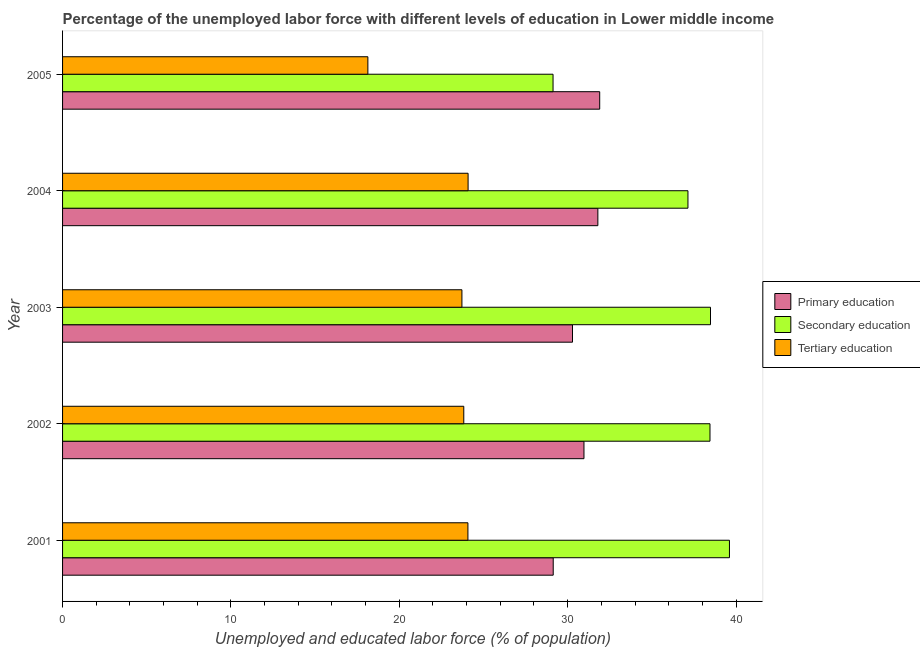How many different coloured bars are there?
Ensure brevity in your answer.  3. How many groups of bars are there?
Your answer should be compact. 5. Are the number of bars per tick equal to the number of legend labels?
Give a very brief answer. Yes. Are the number of bars on each tick of the Y-axis equal?
Offer a terse response. Yes. How many bars are there on the 1st tick from the top?
Provide a short and direct response. 3. How many bars are there on the 4th tick from the bottom?
Provide a short and direct response. 3. What is the label of the 1st group of bars from the top?
Offer a terse response. 2005. What is the percentage of labor force who received secondary education in 2004?
Provide a short and direct response. 37.14. Across all years, what is the maximum percentage of labor force who received secondary education?
Make the answer very short. 39.61. Across all years, what is the minimum percentage of labor force who received primary education?
Provide a succinct answer. 29.14. In which year was the percentage of labor force who received secondary education maximum?
Provide a short and direct response. 2001. In which year was the percentage of labor force who received secondary education minimum?
Your answer should be very brief. 2005. What is the total percentage of labor force who received tertiary education in the graph?
Your response must be concise. 113.84. What is the difference between the percentage of labor force who received primary education in 2001 and that in 2004?
Give a very brief answer. -2.65. What is the difference between the percentage of labor force who received primary education in 2004 and the percentage of labor force who received tertiary education in 2001?
Provide a succinct answer. 7.72. What is the average percentage of labor force who received secondary education per year?
Give a very brief answer. 36.56. In the year 2001, what is the difference between the percentage of labor force who received secondary education and percentage of labor force who received primary education?
Keep it short and to the point. 10.47. In how many years, is the percentage of labor force who received secondary education greater than 36 %?
Ensure brevity in your answer.  4. What is the ratio of the percentage of labor force who received primary education in 2001 to that in 2003?
Your response must be concise. 0.96. Is the percentage of labor force who received tertiary education in 2003 less than that in 2004?
Provide a succinct answer. Yes. Is the difference between the percentage of labor force who received primary education in 2003 and 2004 greater than the difference between the percentage of labor force who received secondary education in 2003 and 2004?
Keep it short and to the point. No. What is the difference between the highest and the second highest percentage of labor force who received secondary education?
Provide a short and direct response. 1.13. What is the difference between the highest and the lowest percentage of labor force who received primary education?
Keep it short and to the point. 2.76. What does the 3rd bar from the bottom in 2002 represents?
Offer a very short reply. Tertiary education. Is it the case that in every year, the sum of the percentage of labor force who received primary education and percentage of labor force who received secondary education is greater than the percentage of labor force who received tertiary education?
Your answer should be compact. Yes. How many years are there in the graph?
Provide a succinct answer. 5. Are the values on the major ticks of X-axis written in scientific E-notation?
Give a very brief answer. No. Does the graph contain any zero values?
Ensure brevity in your answer.  No. How many legend labels are there?
Offer a very short reply. 3. What is the title of the graph?
Keep it short and to the point. Percentage of the unemployed labor force with different levels of education in Lower middle income. Does "Oil" appear as one of the legend labels in the graph?
Ensure brevity in your answer.  No. What is the label or title of the X-axis?
Your answer should be very brief. Unemployed and educated labor force (% of population). What is the label or title of the Y-axis?
Offer a terse response. Year. What is the Unemployed and educated labor force (% of population) of Primary education in 2001?
Your answer should be compact. 29.14. What is the Unemployed and educated labor force (% of population) of Secondary education in 2001?
Provide a short and direct response. 39.61. What is the Unemployed and educated labor force (% of population) in Tertiary education in 2001?
Offer a terse response. 24.08. What is the Unemployed and educated labor force (% of population) of Primary education in 2002?
Provide a succinct answer. 30.97. What is the Unemployed and educated labor force (% of population) in Secondary education in 2002?
Provide a succinct answer. 38.45. What is the Unemployed and educated labor force (% of population) in Tertiary education in 2002?
Ensure brevity in your answer.  23.83. What is the Unemployed and educated labor force (% of population) of Primary education in 2003?
Your answer should be very brief. 30.29. What is the Unemployed and educated labor force (% of population) in Secondary education in 2003?
Provide a succinct answer. 38.48. What is the Unemployed and educated labor force (% of population) in Tertiary education in 2003?
Keep it short and to the point. 23.72. What is the Unemployed and educated labor force (% of population) in Primary education in 2004?
Your response must be concise. 31.79. What is the Unemployed and educated labor force (% of population) in Secondary education in 2004?
Your answer should be very brief. 37.14. What is the Unemployed and educated labor force (% of population) in Tertiary education in 2004?
Your answer should be compact. 24.09. What is the Unemployed and educated labor force (% of population) of Primary education in 2005?
Your answer should be compact. 31.9. What is the Unemployed and educated labor force (% of population) in Secondary education in 2005?
Offer a terse response. 29.13. What is the Unemployed and educated labor force (% of population) in Tertiary education in 2005?
Your response must be concise. 18.13. Across all years, what is the maximum Unemployed and educated labor force (% of population) of Primary education?
Your answer should be compact. 31.9. Across all years, what is the maximum Unemployed and educated labor force (% of population) of Secondary education?
Offer a terse response. 39.61. Across all years, what is the maximum Unemployed and educated labor force (% of population) of Tertiary education?
Give a very brief answer. 24.09. Across all years, what is the minimum Unemployed and educated labor force (% of population) in Primary education?
Your answer should be very brief. 29.14. Across all years, what is the minimum Unemployed and educated labor force (% of population) in Secondary education?
Provide a succinct answer. 29.13. Across all years, what is the minimum Unemployed and educated labor force (% of population) in Tertiary education?
Provide a short and direct response. 18.13. What is the total Unemployed and educated labor force (% of population) of Primary education in the graph?
Ensure brevity in your answer.  154.09. What is the total Unemployed and educated labor force (% of population) of Secondary education in the graph?
Provide a short and direct response. 182.82. What is the total Unemployed and educated labor force (% of population) in Tertiary education in the graph?
Make the answer very short. 113.84. What is the difference between the Unemployed and educated labor force (% of population) in Primary education in 2001 and that in 2002?
Provide a succinct answer. -1.83. What is the difference between the Unemployed and educated labor force (% of population) in Secondary education in 2001 and that in 2002?
Keep it short and to the point. 1.16. What is the difference between the Unemployed and educated labor force (% of population) of Tertiary education in 2001 and that in 2002?
Your response must be concise. 0.25. What is the difference between the Unemployed and educated labor force (% of population) of Primary education in 2001 and that in 2003?
Your answer should be very brief. -1.15. What is the difference between the Unemployed and educated labor force (% of population) of Secondary education in 2001 and that in 2003?
Keep it short and to the point. 1.13. What is the difference between the Unemployed and educated labor force (% of population) in Tertiary education in 2001 and that in 2003?
Make the answer very short. 0.36. What is the difference between the Unemployed and educated labor force (% of population) of Primary education in 2001 and that in 2004?
Your answer should be very brief. -2.65. What is the difference between the Unemployed and educated labor force (% of population) of Secondary education in 2001 and that in 2004?
Offer a very short reply. 2.46. What is the difference between the Unemployed and educated labor force (% of population) of Tertiary education in 2001 and that in 2004?
Your answer should be very brief. -0.01. What is the difference between the Unemployed and educated labor force (% of population) of Primary education in 2001 and that in 2005?
Offer a very short reply. -2.76. What is the difference between the Unemployed and educated labor force (% of population) of Secondary education in 2001 and that in 2005?
Offer a terse response. 10.48. What is the difference between the Unemployed and educated labor force (% of population) in Tertiary education in 2001 and that in 2005?
Provide a short and direct response. 5.94. What is the difference between the Unemployed and educated labor force (% of population) in Primary education in 2002 and that in 2003?
Your answer should be very brief. 0.68. What is the difference between the Unemployed and educated labor force (% of population) in Secondary education in 2002 and that in 2003?
Provide a succinct answer. -0.03. What is the difference between the Unemployed and educated labor force (% of population) of Tertiary education in 2002 and that in 2003?
Your response must be concise. 0.11. What is the difference between the Unemployed and educated labor force (% of population) of Primary education in 2002 and that in 2004?
Keep it short and to the point. -0.83. What is the difference between the Unemployed and educated labor force (% of population) of Secondary education in 2002 and that in 2004?
Provide a succinct answer. 1.31. What is the difference between the Unemployed and educated labor force (% of population) of Tertiary education in 2002 and that in 2004?
Your answer should be very brief. -0.26. What is the difference between the Unemployed and educated labor force (% of population) in Primary education in 2002 and that in 2005?
Ensure brevity in your answer.  -0.93. What is the difference between the Unemployed and educated labor force (% of population) of Secondary education in 2002 and that in 2005?
Ensure brevity in your answer.  9.32. What is the difference between the Unemployed and educated labor force (% of population) in Tertiary education in 2002 and that in 2005?
Offer a terse response. 5.7. What is the difference between the Unemployed and educated labor force (% of population) of Primary education in 2003 and that in 2004?
Ensure brevity in your answer.  -1.51. What is the difference between the Unemployed and educated labor force (% of population) of Secondary education in 2003 and that in 2004?
Make the answer very short. 1.34. What is the difference between the Unemployed and educated labor force (% of population) in Tertiary education in 2003 and that in 2004?
Give a very brief answer. -0.37. What is the difference between the Unemployed and educated labor force (% of population) of Primary education in 2003 and that in 2005?
Provide a short and direct response. -1.62. What is the difference between the Unemployed and educated labor force (% of population) in Secondary education in 2003 and that in 2005?
Offer a very short reply. 9.35. What is the difference between the Unemployed and educated labor force (% of population) of Tertiary education in 2003 and that in 2005?
Your response must be concise. 5.59. What is the difference between the Unemployed and educated labor force (% of population) in Primary education in 2004 and that in 2005?
Give a very brief answer. -0.11. What is the difference between the Unemployed and educated labor force (% of population) of Secondary education in 2004 and that in 2005?
Your response must be concise. 8.01. What is the difference between the Unemployed and educated labor force (% of population) of Tertiary education in 2004 and that in 2005?
Your answer should be compact. 5.95. What is the difference between the Unemployed and educated labor force (% of population) in Primary education in 2001 and the Unemployed and educated labor force (% of population) in Secondary education in 2002?
Ensure brevity in your answer.  -9.31. What is the difference between the Unemployed and educated labor force (% of population) in Primary education in 2001 and the Unemployed and educated labor force (% of population) in Tertiary education in 2002?
Provide a short and direct response. 5.31. What is the difference between the Unemployed and educated labor force (% of population) in Secondary education in 2001 and the Unemployed and educated labor force (% of population) in Tertiary education in 2002?
Keep it short and to the point. 15.78. What is the difference between the Unemployed and educated labor force (% of population) in Primary education in 2001 and the Unemployed and educated labor force (% of population) in Secondary education in 2003?
Your answer should be very brief. -9.34. What is the difference between the Unemployed and educated labor force (% of population) in Primary education in 2001 and the Unemployed and educated labor force (% of population) in Tertiary education in 2003?
Ensure brevity in your answer.  5.42. What is the difference between the Unemployed and educated labor force (% of population) of Secondary education in 2001 and the Unemployed and educated labor force (% of population) of Tertiary education in 2003?
Offer a very short reply. 15.89. What is the difference between the Unemployed and educated labor force (% of population) in Primary education in 2001 and the Unemployed and educated labor force (% of population) in Secondary education in 2004?
Provide a succinct answer. -8. What is the difference between the Unemployed and educated labor force (% of population) in Primary education in 2001 and the Unemployed and educated labor force (% of population) in Tertiary education in 2004?
Your answer should be compact. 5.06. What is the difference between the Unemployed and educated labor force (% of population) in Secondary education in 2001 and the Unemployed and educated labor force (% of population) in Tertiary education in 2004?
Ensure brevity in your answer.  15.52. What is the difference between the Unemployed and educated labor force (% of population) in Primary education in 2001 and the Unemployed and educated labor force (% of population) in Secondary education in 2005?
Provide a short and direct response. 0.01. What is the difference between the Unemployed and educated labor force (% of population) in Primary education in 2001 and the Unemployed and educated labor force (% of population) in Tertiary education in 2005?
Your answer should be compact. 11.01. What is the difference between the Unemployed and educated labor force (% of population) in Secondary education in 2001 and the Unemployed and educated labor force (% of population) in Tertiary education in 2005?
Your response must be concise. 21.48. What is the difference between the Unemployed and educated labor force (% of population) in Primary education in 2002 and the Unemployed and educated labor force (% of population) in Secondary education in 2003?
Offer a very short reply. -7.52. What is the difference between the Unemployed and educated labor force (% of population) of Primary education in 2002 and the Unemployed and educated labor force (% of population) of Tertiary education in 2003?
Your response must be concise. 7.25. What is the difference between the Unemployed and educated labor force (% of population) of Secondary education in 2002 and the Unemployed and educated labor force (% of population) of Tertiary education in 2003?
Your response must be concise. 14.73. What is the difference between the Unemployed and educated labor force (% of population) in Primary education in 2002 and the Unemployed and educated labor force (% of population) in Secondary education in 2004?
Offer a very short reply. -6.18. What is the difference between the Unemployed and educated labor force (% of population) of Primary education in 2002 and the Unemployed and educated labor force (% of population) of Tertiary education in 2004?
Your response must be concise. 6.88. What is the difference between the Unemployed and educated labor force (% of population) of Secondary education in 2002 and the Unemployed and educated labor force (% of population) of Tertiary education in 2004?
Provide a succinct answer. 14.37. What is the difference between the Unemployed and educated labor force (% of population) in Primary education in 2002 and the Unemployed and educated labor force (% of population) in Secondary education in 2005?
Keep it short and to the point. 1.84. What is the difference between the Unemployed and educated labor force (% of population) of Primary education in 2002 and the Unemployed and educated labor force (% of population) of Tertiary education in 2005?
Provide a succinct answer. 12.83. What is the difference between the Unemployed and educated labor force (% of population) of Secondary education in 2002 and the Unemployed and educated labor force (% of population) of Tertiary education in 2005?
Give a very brief answer. 20.32. What is the difference between the Unemployed and educated labor force (% of population) in Primary education in 2003 and the Unemployed and educated labor force (% of population) in Secondary education in 2004?
Your answer should be very brief. -6.86. What is the difference between the Unemployed and educated labor force (% of population) of Primary education in 2003 and the Unemployed and educated labor force (% of population) of Tertiary education in 2004?
Keep it short and to the point. 6.2. What is the difference between the Unemployed and educated labor force (% of population) of Secondary education in 2003 and the Unemployed and educated labor force (% of population) of Tertiary education in 2004?
Make the answer very short. 14.4. What is the difference between the Unemployed and educated labor force (% of population) in Primary education in 2003 and the Unemployed and educated labor force (% of population) in Secondary education in 2005?
Keep it short and to the point. 1.16. What is the difference between the Unemployed and educated labor force (% of population) in Primary education in 2003 and the Unemployed and educated labor force (% of population) in Tertiary education in 2005?
Keep it short and to the point. 12.15. What is the difference between the Unemployed and educated labor force (% of population) of Secondary education in 2003 and the Unemployed and educated labor force (% of population) of Tertiary education in 2005?
Keep it short and to the point. 20.35. What is the difference between the Unemployed and educated labor force (% of population) in Primary education in 2004 and the Unemployed and educated labor force (% of population) in Secondary education in 2005?
Make the answer very short. 2.66. What is the difference between the Unemployed and educated labor force (% of population) of Primary education in 2004 and the Unemployed and educated labor force (% of population) of Tertiary education in 2005?
Your response must be concise. 13.66. What is the difference between the Unemployed and educated labor force (% of population) in Secondary education in 2004 and the Unemployed and educated labor force (% of population) in Tertiary education in 2005?
Your answer should be very brief. 19.01. What is the average Unemployed and educated labor force (% of population) of Primary education per year?
Give a very brief answer. 30.82. What is the average Unemployed and educated labor force (% of population) in Secondary education per year?
Provide a short and direct response. 36.56. What is the average Unemployed and educated labor force (% of population) of Tertiary education per year?
Provide a succinct answer. 22.77. In the year 2001, what is the difference between the Unemployed and educated labor force (% of population) in Primary education and Unemployed and educated labor force (% of population) in Secondary education?
Your answer should be very brief. -10.47. In the year 2001, what is the difference between the Unemployed and educated labor force (% of population) of Primary education and Unemployed and educated labor force (% of population) of Tertiary education?
Provide a short and direct response. 5.07. In the year 2001, what is the difference between the Unemployed and educated labor force (% of population) of Secondary education and Unemployed and educated labor force (% of population) of Tertiary education?
Keep it short and to the point. 15.53. In the year 2002, what is the difference between the Unemployed and educated labor force (% of population) in Primary education and Unemployed and educated labor force (% of population) in Secondary education?
Your response must be concise. -7.49. In the year 2002, what is the difference between the Unemployed and educated labor force (% of population) of Primary education and Unemployed and educated labor force (% of population) of Tertiary education?
Keep it short and to the point. 7.14. In the year 2002, what is the difference between the Unemployed and educated labor force (% of population) of Secondary education and Unemployed and educated labor force (% of population) of Tertiary education?
Provide a short and direct response. 14.62. In the year 2003, what is the difference between the Unemployed and educated labor force (% of population) in Primary education and Unemployed and educated labor force (% of population) in Secondary education?
Ensure brevity in your answer.  -8.2. In the year 2003, what is the difference between the Unemployed and educated labor force (% of population) of Primary education and Unemployed and educated labor force (% of population) of Tertiary education?
Make the answer very short. 6.57. In the year 2003, what is the difference between the Unemployed and educated labor force (% of population) in Secondary education and Unemployed and educated labor force (% of population) in Tertiary education?
Offer a terse response. 14.76. In the year 2004, what is the difference between the Unemployed and educated labor force (% of population) in Primary education and Unemployed and educated labor force (% of population) in Secondary education?
Your response must be concise. -5.35. In the year 2004, what is the difference between the Unemployed and educated labor force (% of population) of Primary education and Unemployed and educated labor force (% of population) of Tertiary education?
Provide a short and direct response. 7.71. In the year 2004, what is the difference between the Unemployed and educated labor force (% of population) of Secondary education and Unemployed and educated labor force (% of population) of Tertiary education?
Your response must be concise. 13.06. In the year 2005, what is the difference between the Unemployed and educated labor force (% of population) of Primary education and Unemployed and educated labor force (% of population) of Secondary education?
Your answer should be very brief. 2.77. In the year 2005, what is the difference between the Unemployed and educated labor force (% of population) in Primary education and Unemployed and educated labor force (% of population) in Tertiary education?
Your answer should be compact. 13.77. In the year 2005, what is the difference between the Unemployed and educated labor force (% of population) of Secondary education and Unemployed and educated labor force (% of population) of Tertiary education?
Provide a short and direct response. 11. What is the ratio of the Unemployed and educated labor force (% of population) of Primary education in 2001 to that in 2002?
Provide a short and direct response. 0.94. What is the ratio of the Unemployed and educated labor force (% of population) of Secondary education in 2001 to that in 2002?
Provide a succinct answer. 1.03. What is the ratio of the Unemployed and educated labor force (% of population) of Tertiary education in 2001 to that in 2002?
Your answer should be very brief. 1.01. What is the ratio of the Unemployed and educated labor force (% of population) in Primary education in 2001 to that in 2003?
Your response must be concise. 0.96. What is the ratio of the Unemployed and educated labor force (% of population) in Secondary education in 2001 to that in 2003?
Offer a terse response. 1.03. What is the ratio of the Unemployed and educated labor force (% of population) in Tertiary education in 2001 to that in 2003?
Your answer should be very brief. 1.01. What is the ratio of the Unemployed and educated labor force (% of population) of Primary education in 2001 to that in 2004?
Offer a very short reply. 0.92. What is the ratio of the Unemployed and educated labor force (% of population) of Secondary education in 2001 to that in 2004?
Your answer should be very brief. 1.07. What is the ratio of the Unemployed and educated labor force (% of population) of Primary education in 2001 to that in 2005?
Provide a succinct answer. 0.91. What is the ratio of the Unemployed and educated labor force (% of population) in Secondary education in 2001 to that in 2005?
Ensure brevity in your answer.  1.36. What is the ratio of the Unemployed and educated labor force (% of population) of Tertiary education in 2001 to that in 2005?
Your answer should be compact. 1.33. What is the ratio of the Unemployed and educated labor force (% of population) in Primary education in 2002 to that in 2003?
Keep it short and to the point. 1.02. What is the ratio of the Unemployed and educated labor force (% of population) in Secondary education in 2002 to that in 2003?
Your response must be concise. 1. What is the ratio of the Unemployed and educated labor force (% of population) of Secondary education in 2002 to that in 2004?
Make the answer very short. 1.04. What is the ratio of the Unemployed and educated labor force (% of population) in Primary education in 2002 to that in 2005?
Offer a very short reply. 0.97. What is the ratio of the Unemployed and educated labor force (% of population) in Secondary education in 2002 to that in 2005?
Provide a short and direct response. 1.32. What is the ratio of the Unemployed and educated labor force (% of population) of Tertiary education in 2002 to that in 2005?
Your answer should be compact. 1.31. What is the ratio of the Unemployed and educated labor force (% of population) of Primary education in 2003 to that in 2004?
Make the answer very short. 0.95. What is the ratio of the Unemployed and educated labor force (% of population) of Secondary education in 2003 to that in 2004?
Make the answer very short. 1.04. What is the ratio of the Unemployed and educated labor force (% of population) in Primary education in 2003 to that in 2005?
Ensure brevity in your answer.  0.95. What is the ratio of the Unemployed and educated labor force (% of population) in Secondary education in 2003 to that in 2005?
Your answer should be compact. 1.32. What is the ratio of the Unemployed and educated labor force (% of population) of Tertiary education in 2003 to that in 2005?
Provide a succinct answer. 1.31. What is the ratio of the Unemployed and educated labor force (% of population) of Primary education in 2004 to that in 2005?
Offer a very short reply. 1. What is the ratio of the Unemployed and educated labor force (% of population) in Secondary education in 2004 to that in 2005?
Your answer should be very brief. 1.27. What is the ratio of the Unemployed and educated labor force (% of population) of Tertiary education in 2004 to that in 2005?
Your response must be concise. 1.33. What is the difference between the highest and the second highest Unemployed and educated labor force (% of population) in Primary education?
Provide a succinct answer. 0.11. What is the difference between the highest and the second highest Unemployed and educated labor force (% of population) of Secondary education?
Ensure brevity in your answer.  1.13. What is the difference between the highest and the second highest Unemployed and educated labor force (% of population) of Tertiary education?
Ensure brevity in your answer.  0.01. What is the difference between the highest and the lowest Unemployed and educated labor force (% of population) of Primary education?
Keep it short and to the point. 2.76. What is the difference between the highest and the lowest Unemployed and educated labor force (% of population) in Secondary education?
Provide a succinct answer. 10.48. What is the difference between the highest and the lowest Unemployed and educated labor force (% of population) in Tertiary education?
Provide a short and direct response. 5.95. 